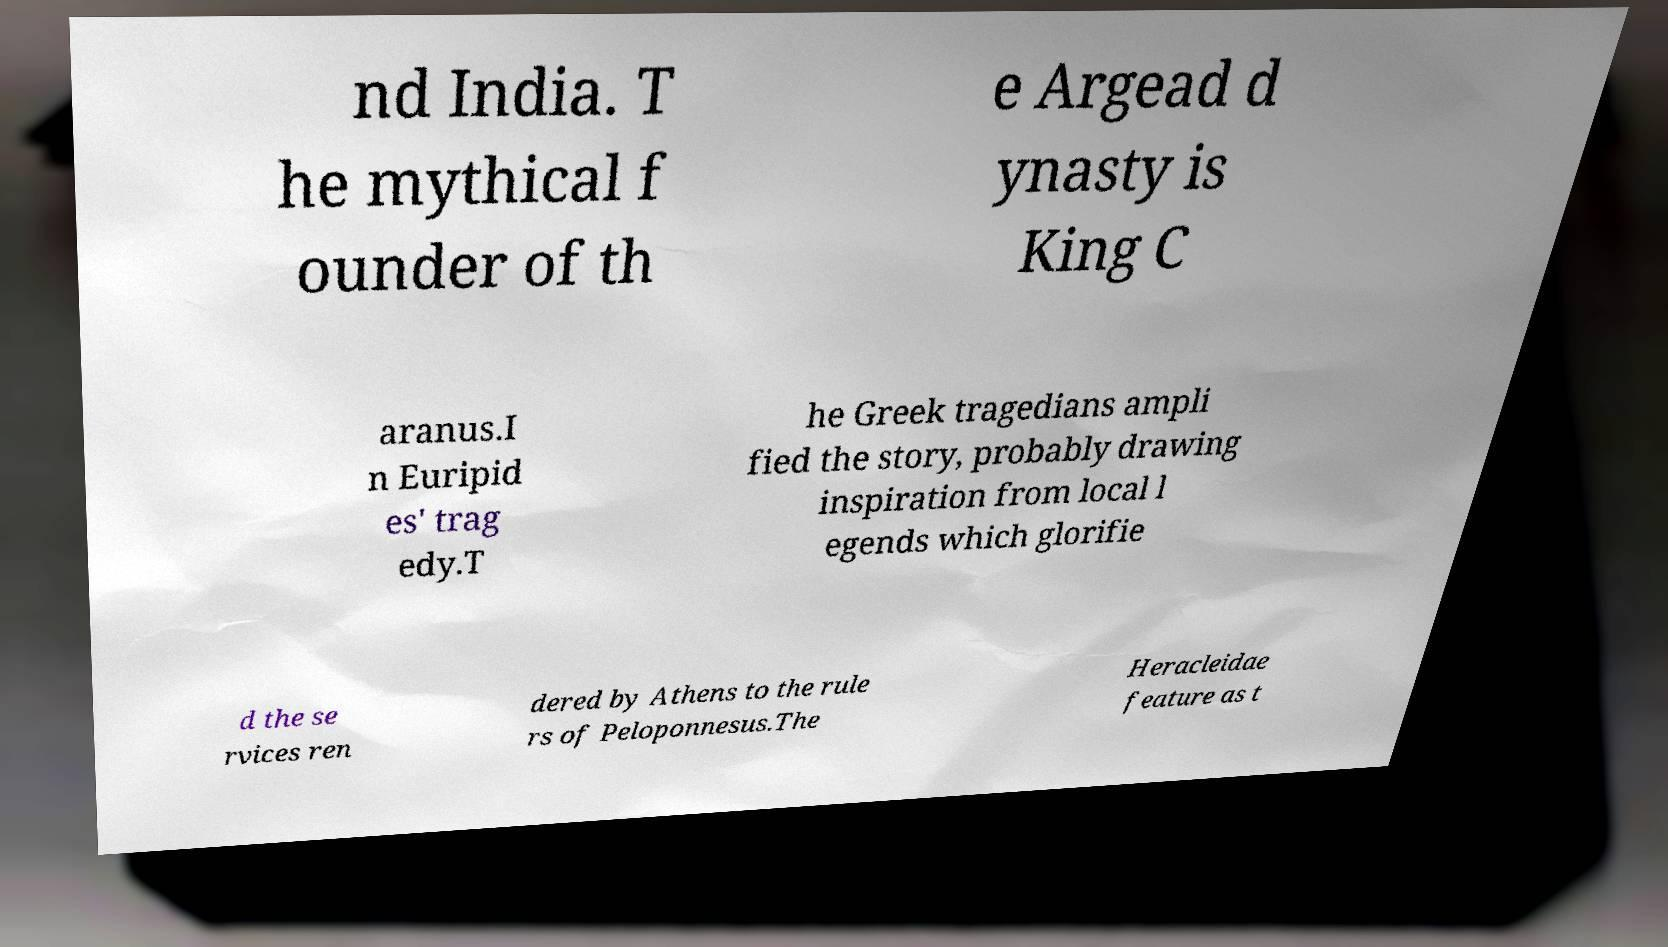Please read and relay the text visible in this image. What does it say? nd India. T he mythical f ounder of th e Argead d ynasty is King C aranus.I n Euripid es' trag edy.T he Greek tragedians ampli fied the story, probably drawing inspiration from local l egends which glorifie d the se rvices ren dered by Athens to the rule rs of Peloponnesus.The Heracleidae feature as t 